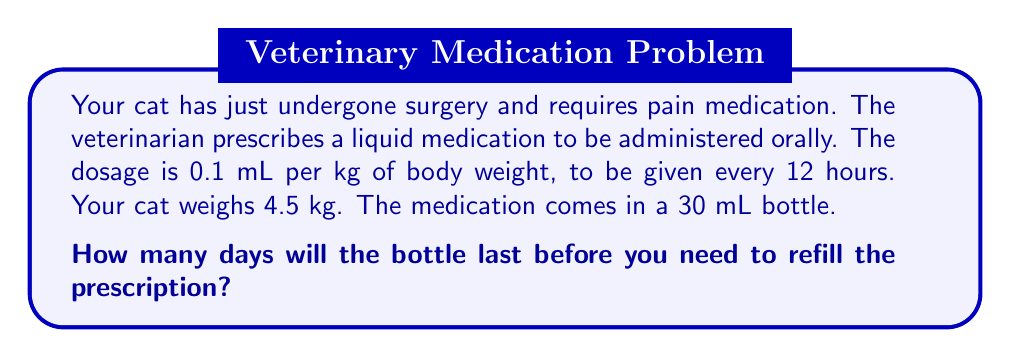Give your solution to this math problem. Let's break this down step-by-step:

1. Calculate the dosage for your cat:
   Dosage = Weight × Dose per kg
   $$ \text{Dosage} = 4.5 \text{ kg} \times 0.1 \text{ mL/kg} = 0.45 \text{ mL} $$

2. Calculate the daily dosage:
   The medication is given every 12 hours, so twice a day.
   $$ \text{Daily dosage} = 0.45 \text{ mL} \times 2 = 0.9 \text{ mL/day} $$

3. Calculate how many days the 30 mL bottle will last:
   $$ \text{Days} = \frac{\text{Bottle volume}}{\text{Daily dosage}} = \frac{30 \text{ mL}}{0.9 \text{ mL/day}} = 33.33 \text{ days} $$

4. Since we can't administer partial days, we round down to the nearest whole number:
   $$ \text{Days} = \lfloor 33.33 \rfloor = 33 \text{ days} $$

Therefore, the 30 mL bottle will last for 33 days before you need to refill the prescription.
Answer: 33 days 